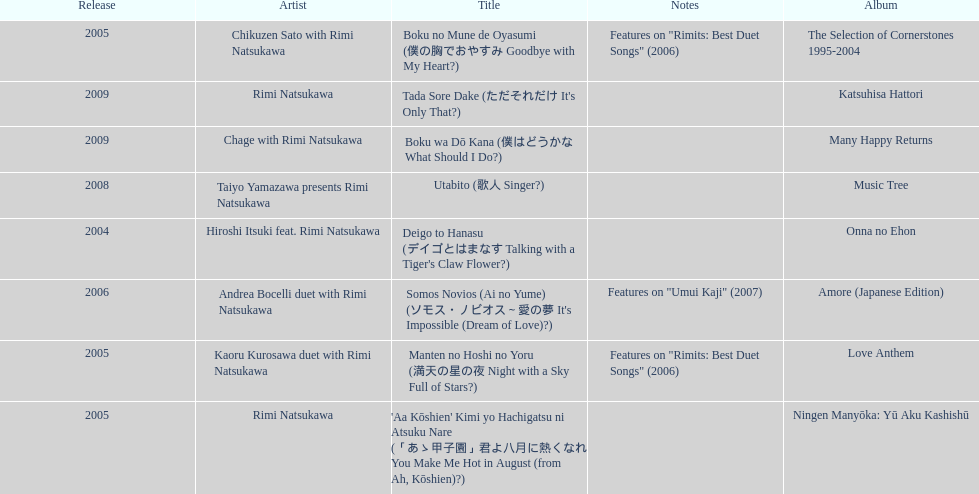Which year witnessed the greatest number of title releases? 2005. 